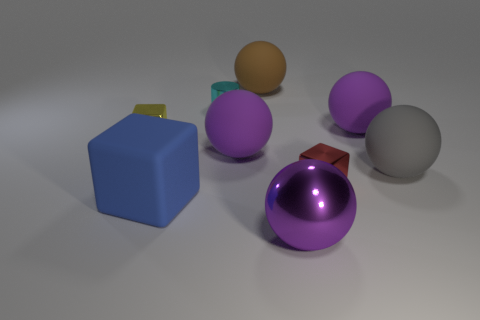Can you tell me what time of day it might be based on the lighting in the scene? Based on the lighting in the scene, it is not possible to determine the time of day. The image appears to be a rendered composition with artificial lighting that doesn't correspond to natural light, thereby not giving any accurate indication of the time of day. 